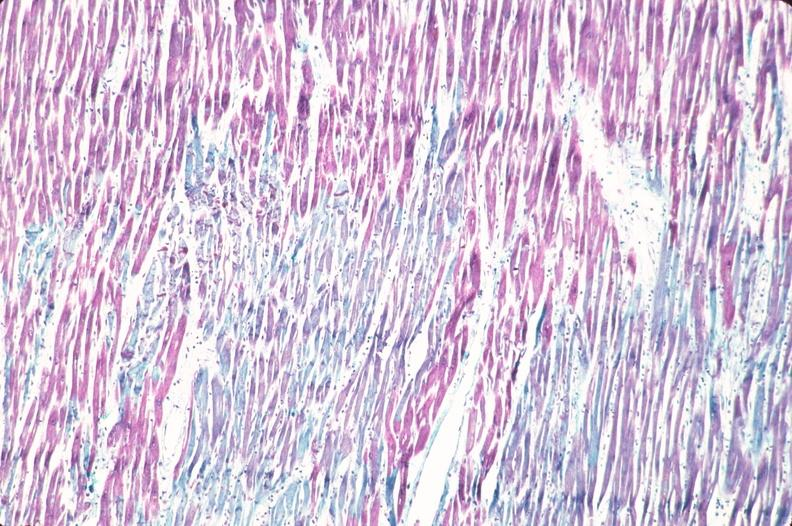what stain?
Answer the question using a single word or phrase. Heart, acute myocardial infarction, aldehyde fuscin 